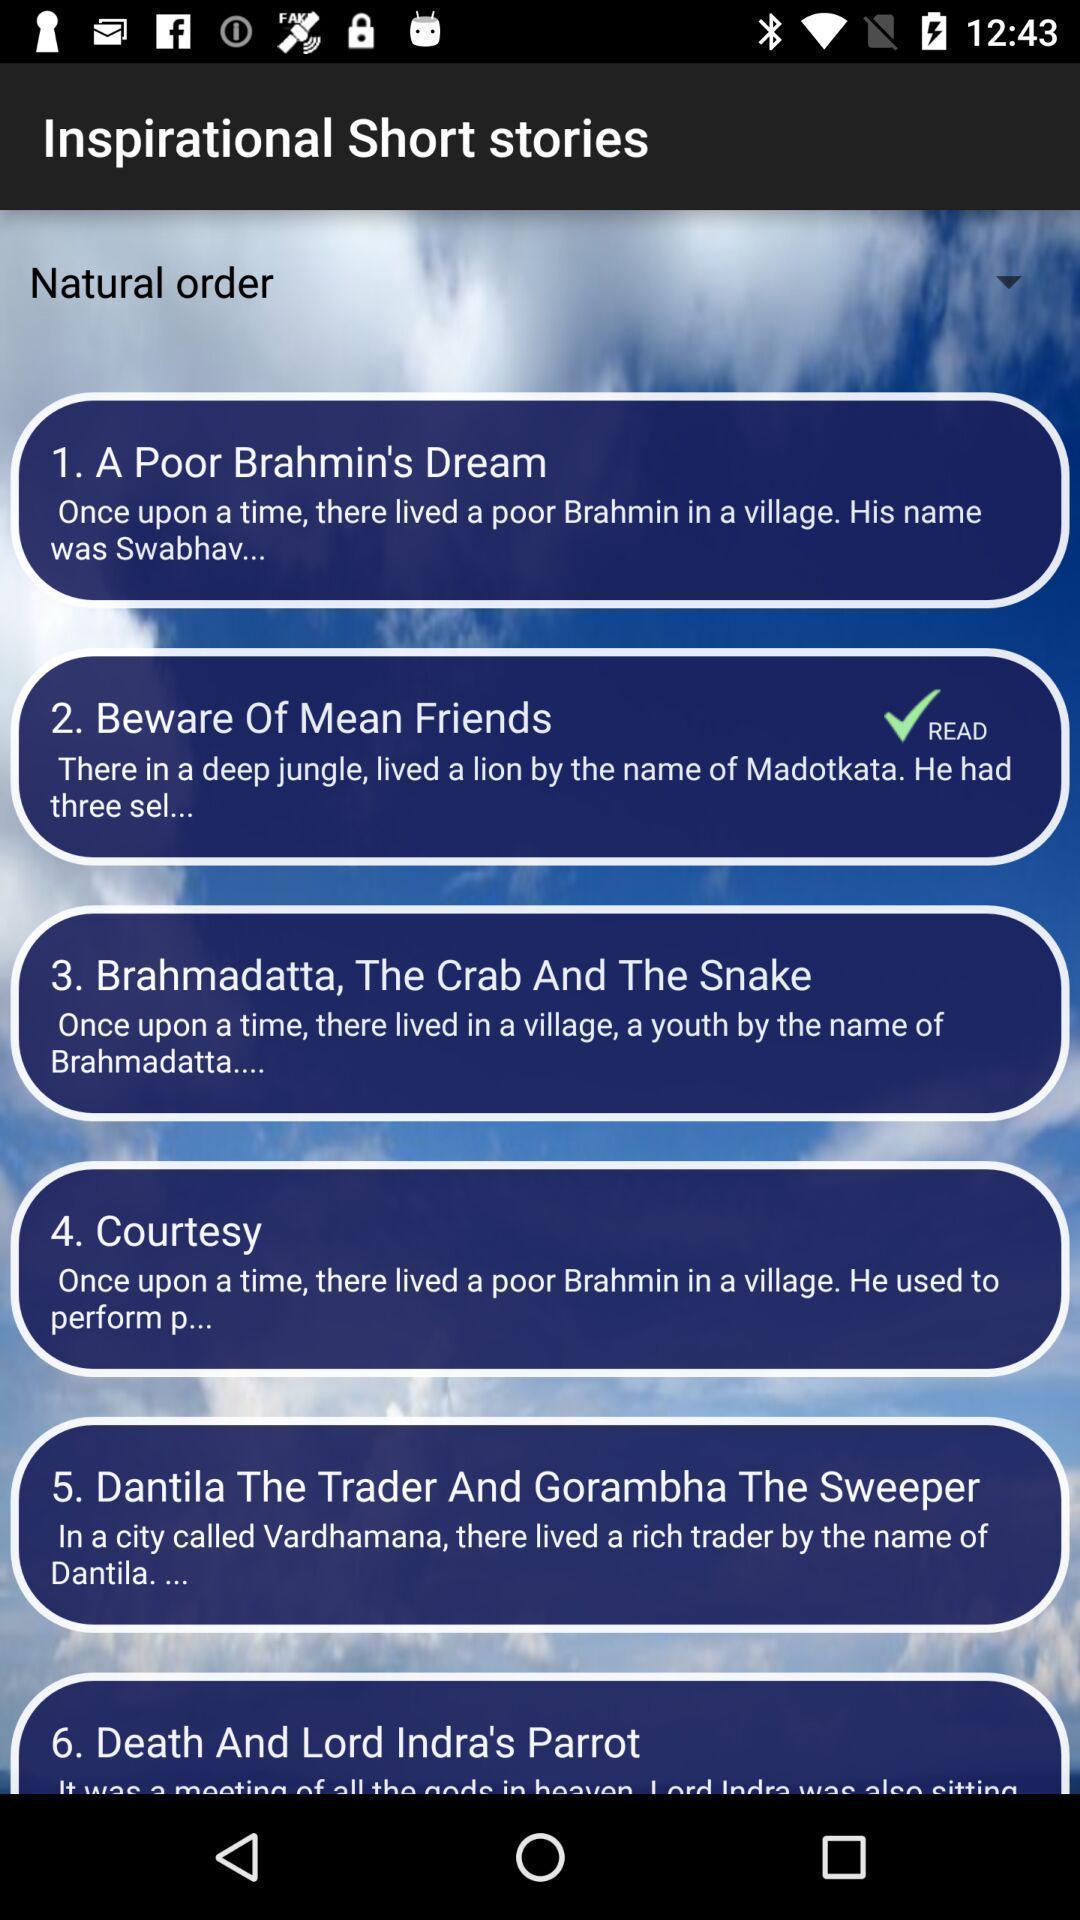Explain what's happening in this screen capture. Screen displaying different short stories. 